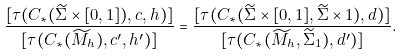<formula> <loc_0><loc_0><loc_500><loc_500>\frac { [ \tau ( C _ { * } ( \widetilde { \Sigma } \times [ 0 , 1 ] ) , c , h ) ] } { [ \tau ( C _ { * } ( \widetilde { M } _ { h } ) , c ^ { \prime } , h ^ { \prime } ) ] } = \frac { [ \tau ( C _ { * } ( \widetilde { \Sigma } \times [ 0 , 1 ] , \widetilde { \Sigma } \times 1 ) , d ) ] } { [ \tau ( C _ { * } ( \widetilde { M } _ { h } , \widetilde { \Sigma } _ { 1 } ) , d ^ { \prime } ) ] } .</formula> 